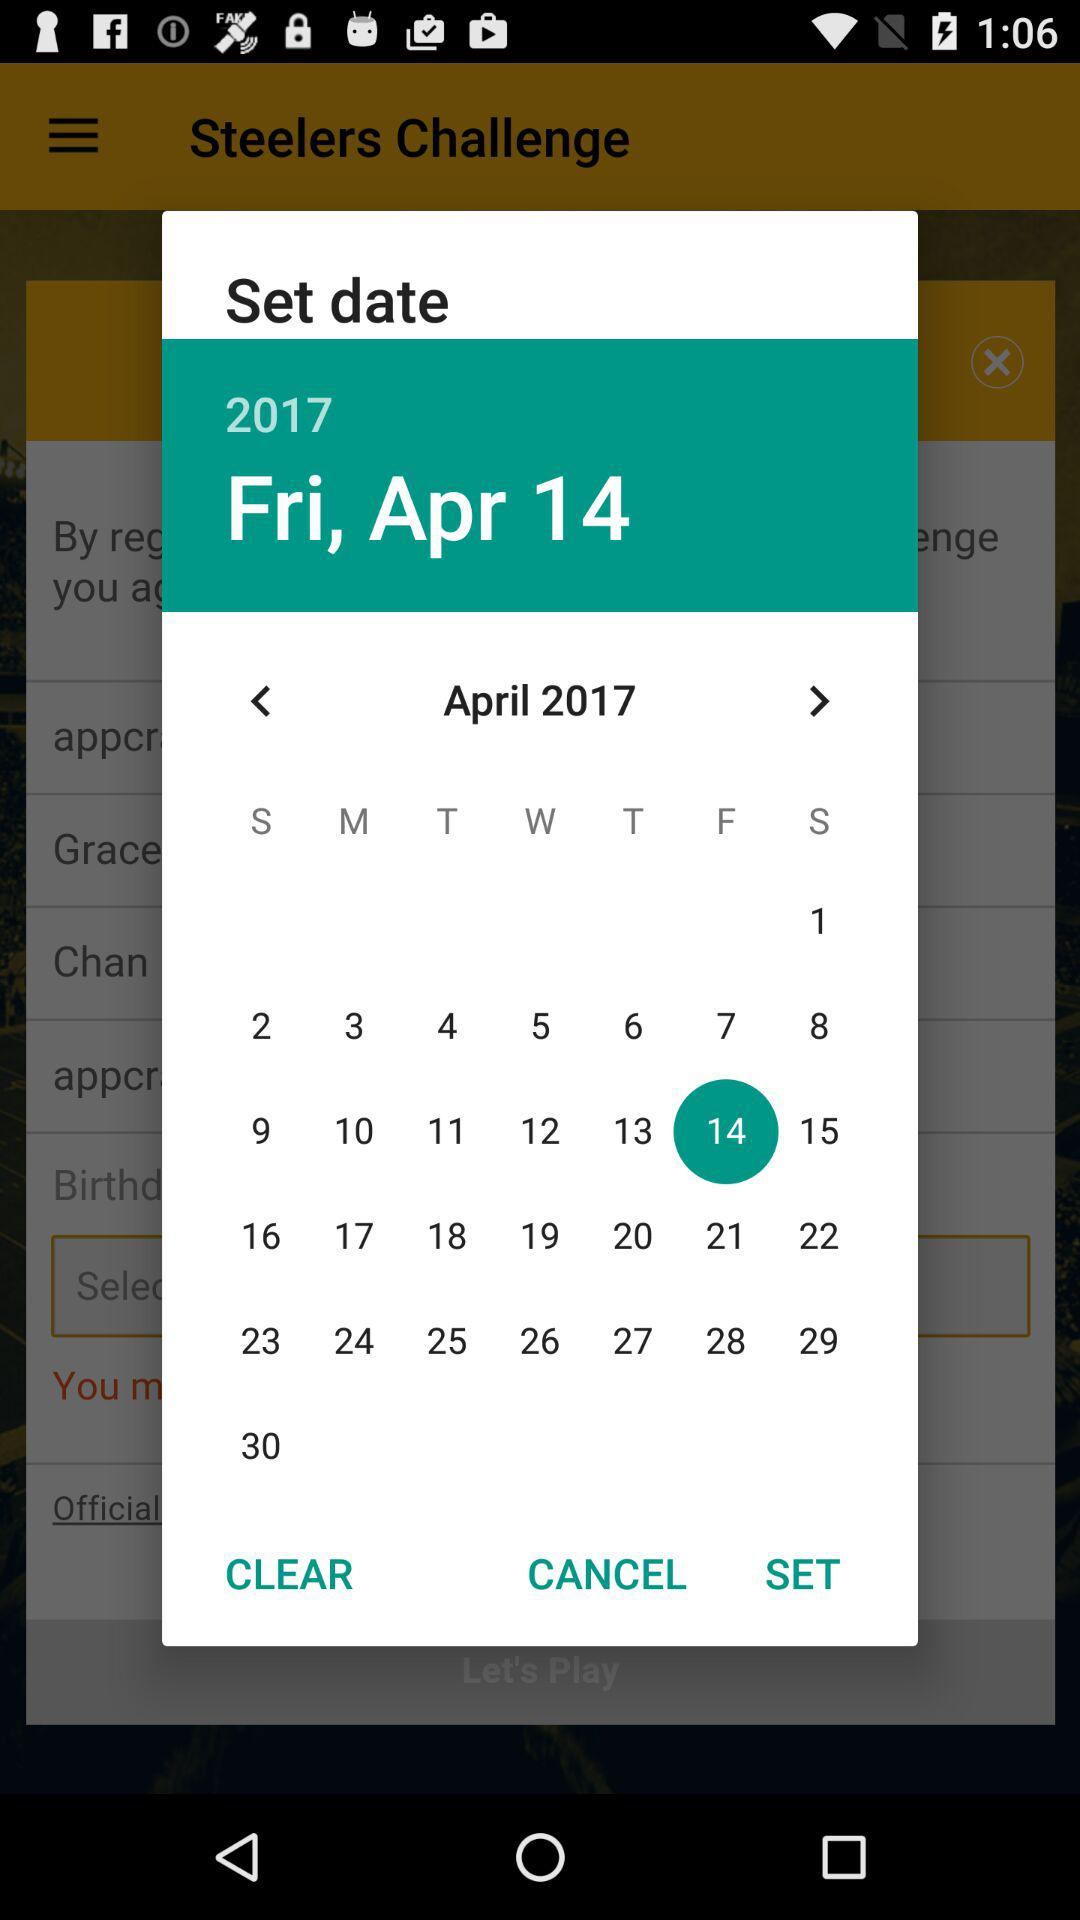Which year's calendar is it? It is the calendar of 2017. 